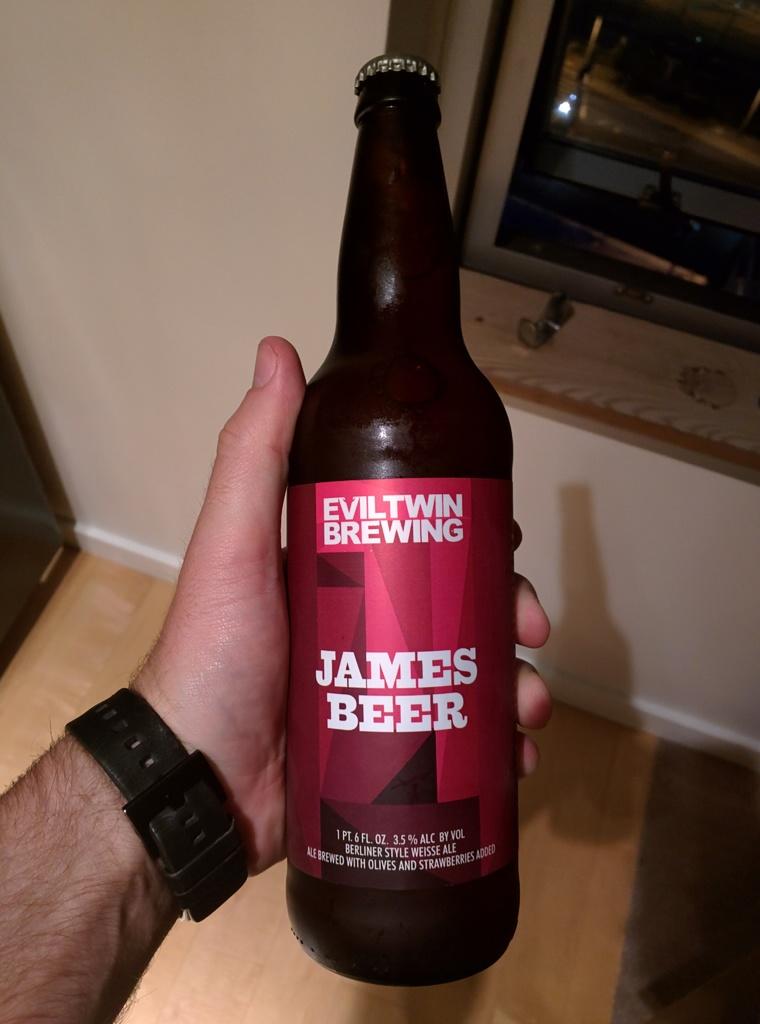What is the brand of beer?
Your response must be concise. James beer. Who brewed the beer?
Make the answer very short. Eviltwin brewing. 